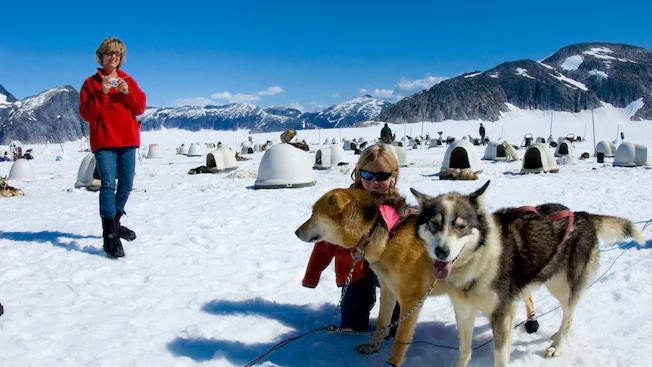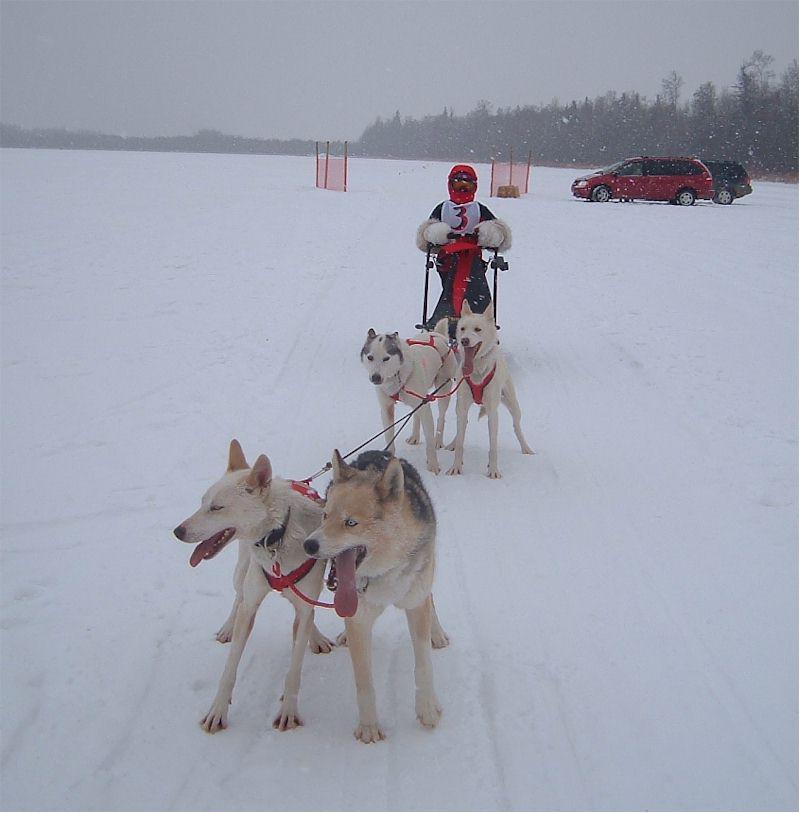The first image is the image on the left, the second image is the image on the right. Evaluate the accuracy of this statement regarding the images: "A figure in red outerwear stands behind a rightward-angled sled with no passenger, pulled by at least one dog figure.". Is it true? Answer yes or no. No. The first image is the image on the left, the second image is the image on the right. Evaluate the accuracy of this statement regarding the images: "The person on the sled in the image on the right is wearing a red jacket.". Is it true? Answer yes or no. No. 